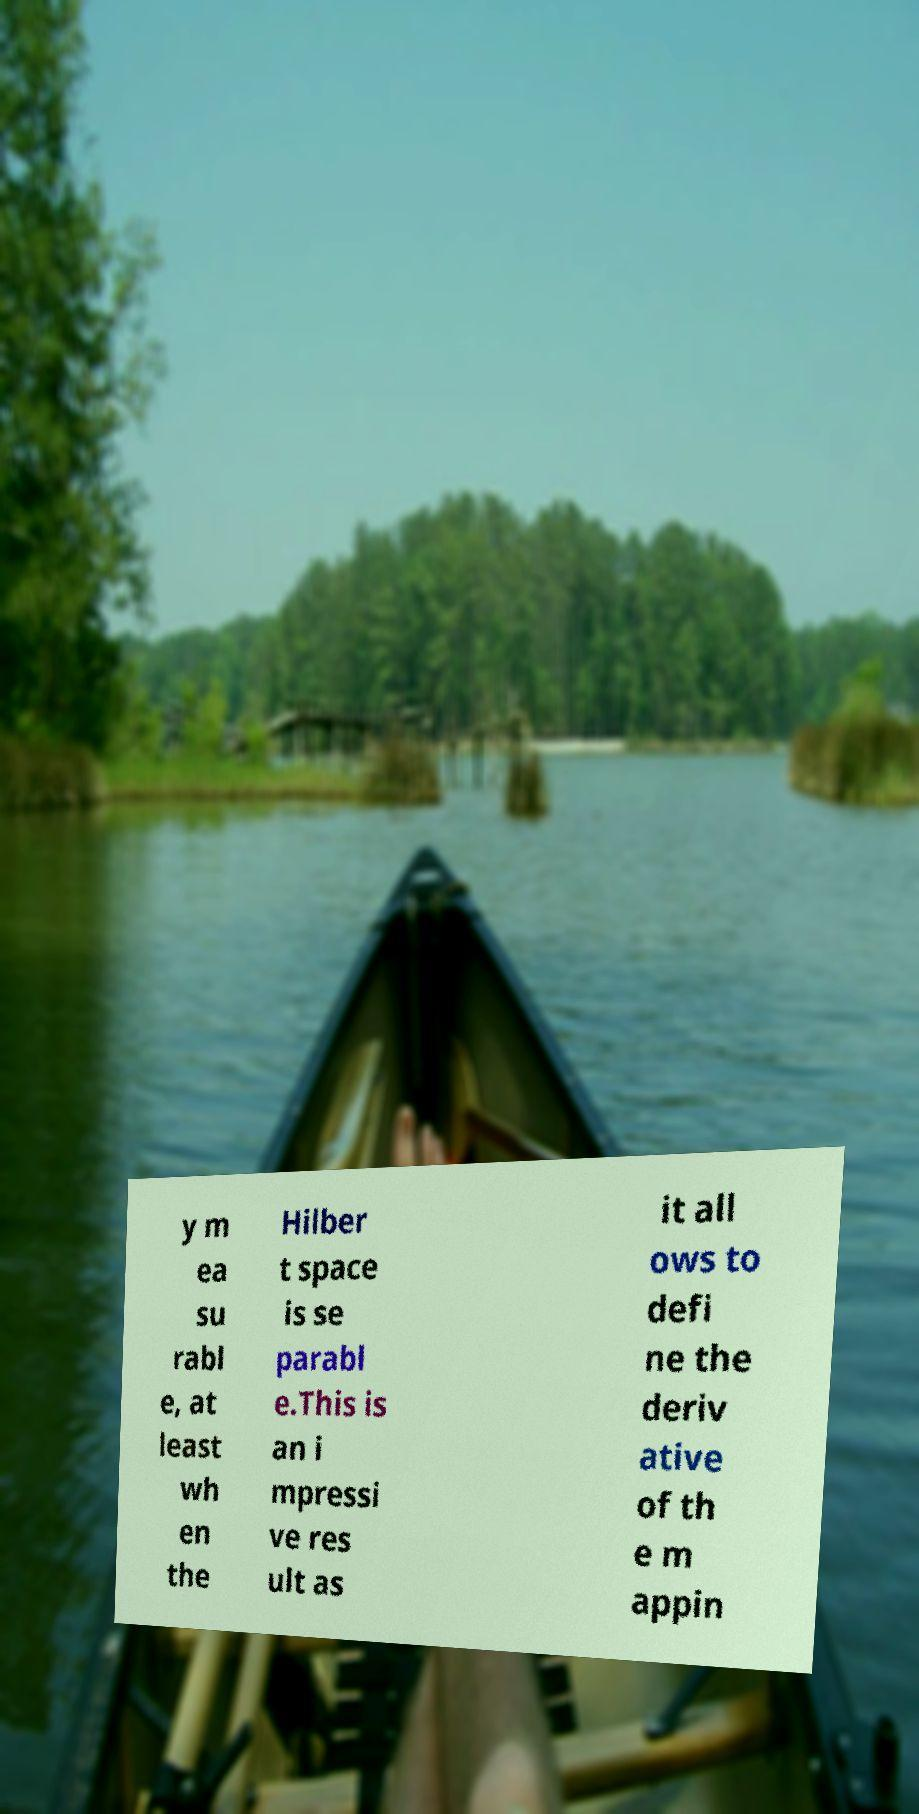Can you read and provide the text displayed in the image?This photo seems to have some interesting text. Can you extract and type it out for me? y m ea su rabl e, at least wh en the Hilber t space is se parabl e.This is an i mpressi ve res ult as it all ows to defi ne the deriv ative of th e m appin 